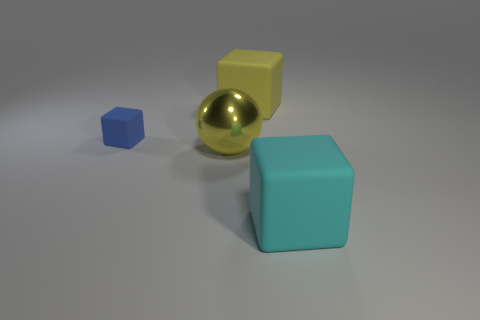Does the arrangement of these objects suggest any particular pattern or relationship? The arrangement of the objects appears to be deliberate, showing a progression in size from the smallest blue cube to the largest teal cube. This might suggest a concept of scaling or hierarchical representation in size. Additionally, the objects might represent diversity or variability but are bonded by the commonality of their geometric nature. 